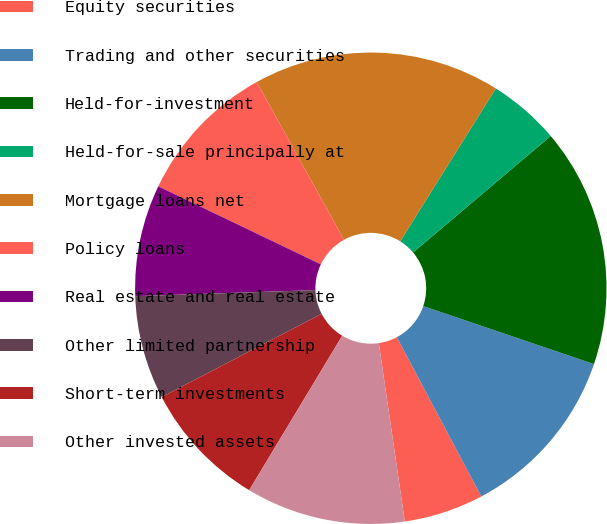<chart> <loc_0><loc_0><loc_500><loc_500><pie_chart><fcel>Equity securities<fcel>Trading and other securities<fcel>Held-for-investment<fcel>Held-for-sale principally at<fcel>Mortgage loans net<fcel>Policy loans<fcel>Real estate and real estate<fcel>Other limited partnership<fcel>Short-term investments<fcel>Other invested assets<nl><fcel>5.46%<fcel>12.02%<fcel>16.39%<fcel>4.92%<fcel>16.94%<fcel>9.84%<fcel>7.65%<fcel>7.1%<fcel>8.74%<fcel>10.93%<nl></chart> 